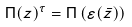Convert formula to latex. <formula><loc_0><loc_0><loc_500><loc_500>\Pi ( z ) ^ { \tau } = \Pi \left ( \varepsilon ( \bar { z } ) \right )</formula> 